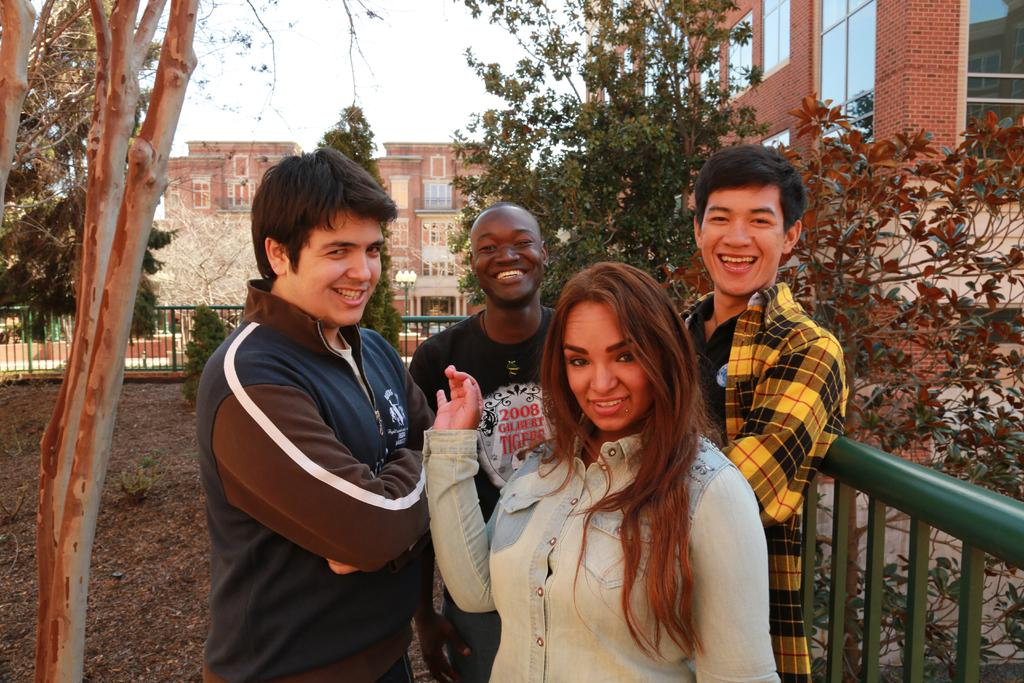How many people are in the image? There are four people standing near the fence in the image. What is on the ground in the image? There are leaves on the ground in the image. What type of vegetation can be seen in the image? There are trees in the image. What type of structures are visible in the image? There are buildings in the image. What is visible in the sky in the image? The sky is visible in the image. What committee is meeting in the image? There is no committee meeting in the image; it features four people standing near a fence. Can you see any sails in the image? There are no sails present in the image. 